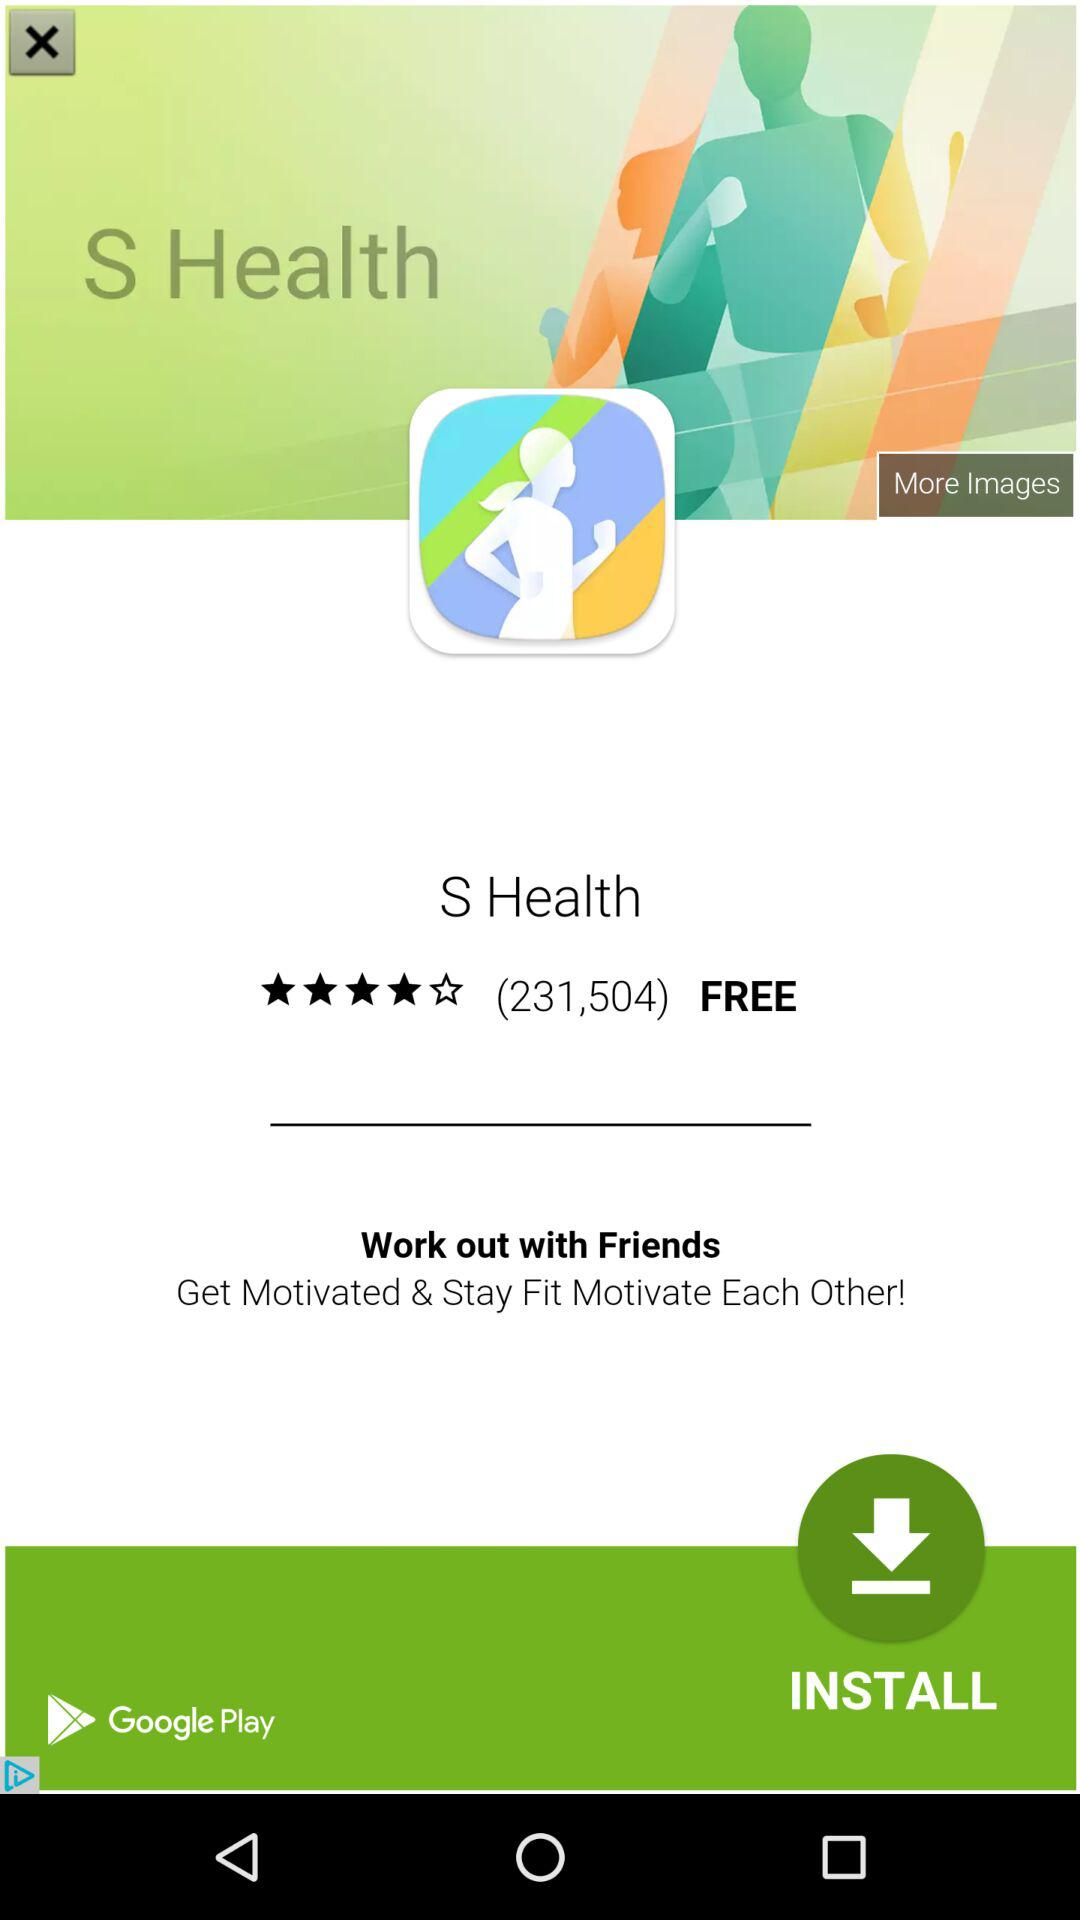What is the given time for beginners? The given time is 03:50. 